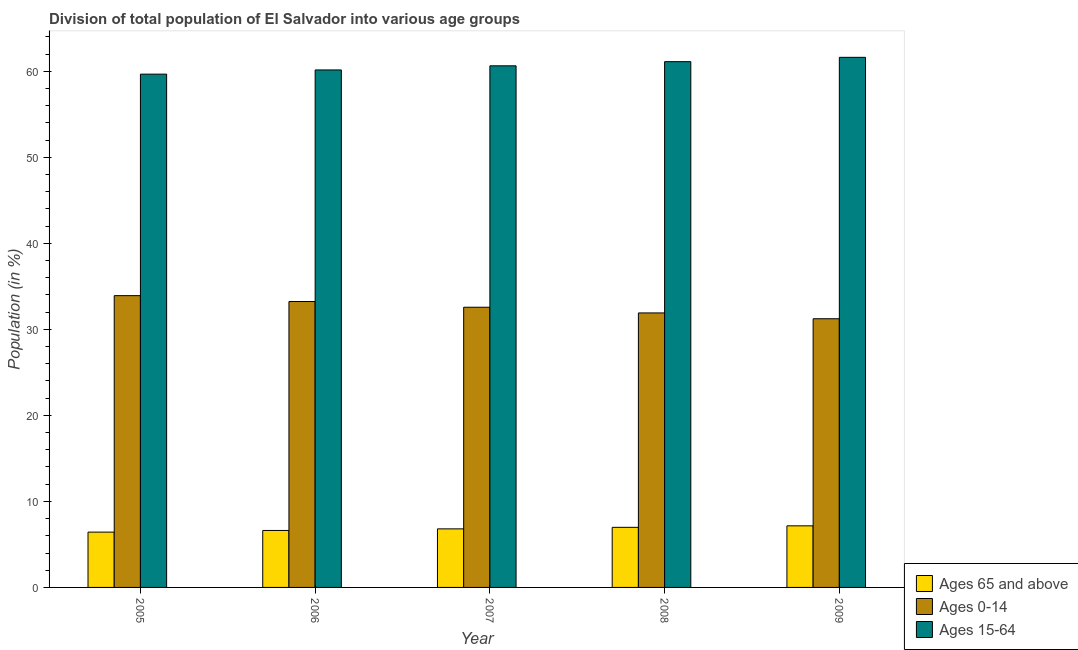How many different coloured bars are there?
Give a very brief answer. 3. How many bars are there on the 2nd tick from the left?
Ensure brevity in your answer.  3. How many bars are there on the 4th tick from the right?
Keep it short and to the point. 3. In how many cases, is the number of bars for a given year not equal to the number of legend labels?
Offer a terse response. 0. What is the percentage of population within the age-group of 65 and above in 2006?
Provide a short and direct response. 6.62. Across all years, what is the maximum percentage of population within the age-group of 65 and above?
Keep it short and to the point. 7.16. Across all years, what is the minimum percentage of population within the age-group 0-14?
Make the answer very short. 31.23. In which year was the percentage of population within the age-group 0-14 minimum?
Make the answer very short. 2009. What is the total percentage of population within the age-group 15-64 in the graph?
Keep it short and to the point. 303.16. What is the difference between the percentage of population within the age-group 0-14 in 2006 and that in 2009?
Your answer should be compact. 2. What is the difference between the percentage of population within the age-group 0-14 in 2008 and the percentage of population within the age-group 15-64 in 2009?
Provide a short and direct response. 0.68. What is the average percentage of population within the age-group of 65 and above per year?
Your response must be concise. 6.8. In the year 2008, what is the difference between the percentage of population within the age-group 15-64 and percentage of population within the age-group of 65 and above?
Keep it short and to the point. 0. What is the ratio of the percentage of population within the age-group 15-64 in 2008 to that in 2009?
Give a very brief answer. 0.99. Is the percentage of population within the age-group of 65 and above in 2005 less than that in 2006?
Offer a terse response. Yes. What is the difference between the highest and the second highest percentage of population within the age-group 0-14?
Your answer should be very brief. 0.68. What is the difference between the highest and the lowest percentage of population within the age-group 0-14?
Give a very brief answer. 2.68. Is the sum of the percentage of population within the age-group 15-64 in 2006 and 2007 greater than the maximum percentage of population within the age-group 0-14 across all years?
Give a very brief answer. Yes. What does the 2nd bar from the left in 2005 represents?
Your answer should be compact. Ages 0-14. What does the 1st bar from the right in 2007 represents?
Make the answer very short. Ages 15-64. Does the graph contain any zero values?
Provide a succinct answer. No. Does the graph contain grids?
Offer a very short reply. No. How many legend labels are there?
Your response must be concise. 3. How are the legend labels stacked?
Give a very brief answer. Vertical. What is the title of the graph?
Give a very brief answer. Division of total population of El Salvador into various age groups
. Does "Social Protection and Labor" appear as one of the legend labels in the graph?
Give a very brief answer. No. What is the Population (in %) in Ages 65 and above in 2005?
Make the answer very short. 6.43. What is the Population (in %) of Ages 0-14 in 2005?
Ensure brevity in your answer.  33.91. What is the Population (in %) in Ages 15-64 in 2005?
Your answer should be compact. 59.66. What is the Population (in %) in Ages 65 and above in 2006?
Your response must be concise. 6.62. What is the Population (in %) of Ages 0-14 in 2006?
Provide a short and direct response. 33.23. What is the Population (in %) of Ages 15-64 in 2006?
Your response must be concise. 60.15. What is the Population (in %) in Ages 65 and above in 2007?
Provide a succinct answer. 6.81. What is the Population (in %) in Ages 0-14 in 2007?
Keep it short and to the point. 32.57. What is the Population (in %) of Ages 15-64 in 2007?
Offer a terse response. 60.63. What is the Population (in %) in Ages 65 and above in 2008?
Provide a short and direct response. 6.98. What is the Population (in %) of Ages 0-14 in 2008?
Offer a terse response. 31.91. What is the Population (in %) of Ages 15-64 in 2008?
Ensure brevity in your answer.  61.11. What is the Population (in %) in Ages 65 and above in 2009?
Make the answer very short. 7.16. What is the Population (in %) of Ages 0-14 in 2009?
Provide a succinct answer. 31.23. What is the Population (in %) in Ages 15-64 in 2009?
Your answer should be compact. 61.61. Across all years, what is the maximum Population (in %) in Ages 65 and above?
Offer a very short reply. 7.16. Across all years, what is the maximum Population (in %) of Ages 0-14?
Your answer should be compact. 33.91. Across all years, what is the maximum Population (in %) of Ages 15-64?
Provide a short and direct response. 61.61. Across all years, what is the minimum Population (in %) of Ages 65 and above?
Your answer should be compact. 6.43. Across all years, what is the minimum Population (in %) of Ages 0-14?
Provide a succinct answer. 31.23. Across all years, what is the minimum Population (in %) of Ages 15-64?
Ensure brevity in your answer.  59.66. What is the total Population (in %) of Ages 65 and above in the graph?
Your response must be concise. 34. What is the total Population (in %) in Ages 0-14 in the graph?
Offer a terse response. 162.84. What is the total Population (in %) in Ages 15-64 in the graph?
Your answer should be very brief. 303.16. What is the difference between the Population (in %) in Ages 65 and above in 2005 and that in 2006?
Make the answer very short. -0.19. What is the difference between the Population (in %) in Ages 0-14 in 2005 and that in 2006?
Your answer should be compact. 0.68. What is the difference between the Population (in %) in Ages 15-64 in 2005 and that in 2006?
Offer a terse response. -0.49. What is the difference between the Population (in %) of Ages 65 and above in 2005 and that in 2007?
Your answer should be compact. -0.38. What is the difference between the Population (in %) in Ages 0-14 in 2005 and that in 2007?
Your answer should be very brief. 1.35. What is the difference between the Population (in %) in Ages 15-64 in 2005 and that in 2007?
Provide a short and direct response. -0.97. What is the difference between the Population (in %) of Ages 65 and above in 2005 and that in 2008?
Keep it short and to the point. -0.56. What is the difference between the Population (in %) in Ages 0-14 in 2005 and that in 2008?
Your response must be concise. 2.01. What is the difference between the Population (in %) of Ages 15-64 in 2005 and that in 2008?
Give a very brief answer. -1.45. What is the difference between the Population (in %) in Ages 65 and above in 2005 and that in 2009?
Ensure brevity in your answer.  -0.73. What is the difference between the Population (in %) of Ages 0-14 in 2005 and that in 2009?
Keep it short and to the point. 2.68. What is the difference between the Population (in %) of Ages 15-64 in 2005 and that in 2009?
Make the answer very short. -1.95. What is the difference between the Population (in %) in Ages 65 and above in 2006 and that in 2007?
Your answer should be very brief. -0.18. What is the difference between the Population (in %) in Ages 0-14 in 2006 and that in 2007?
Provide a succinct answer. 0.66. What is the difference between the Population (in %) in Ages 15-64 in 2006 and that in 2007?
Keep it short and to the point. -0.48. What is the difference between the Population (in %) in Ages 65 and above in 2006 and that in 2008?
Give a very brief answer. -0.36. What is the difference between the Population (in %) of Ages 0-14 in 2006 and that in 2008?
Give a very brief answer. 1.33. What is the difference between the Population (in %) of Ages 15-64 in 2006 and that in 2008?
Keep it short and to the point. -0.96. What is the difference between the Population (in %) in Ages 65 and above in 2006 and that in 2009?
Your answer should be very brief. -0.54. What is the difference between the Population (in %) in Ages 0-14 in 2006 and that in 2009?
Ensure brevity in your answer.  2. What is the difference between the Population (in %) in Ages 15-64 in 2006 and that in 2009?
Provide a short and direct response. -1.47. What is the difference between the Population (in %) in Ages 65 and above in 2007 and that in 2008?
Offer a terse response. -0.18. What is the difference between the Population (in %) of Ages 0-14 in 2007 and that in 2008?
Provide a succinct answer. 0.66. What is the difference between the Population (in %) in Ages 15-64 in 2007 and that in 2008?
Keep it short and to the point. -0.48. What is the difference between the Population (in %) of Ages 65 and above in 2007 and that in 2009?
Offer a very short reply. -0.35. What is the difference between the Population (in %) of Ages 0-14 in 2007 and that in 2009?
Offer a terse response. 1.34. What is the difference between the Population (in %) in Ages 15-64 in 2007 and that in 2009?
Make the answer very short. -0.99. What is the difference between the Population (in %) in Ages 65 and above in 2008 and that in 2009?
Ensure brevity in your answer.  -0.17. What is the difference between the Population (in %) in Ages 0-14 in 2008 and that in 2009?
Provide a short and direct response. 0.68. What is the difference between the Population (in %) of Ages 15-64 in 2008 and that in 2009?
Your response must be concise. -0.5. What is the difference between the Population (in %) in Ages 65 and above in 2005 and the Population (in %) in Ages 0-14 in 2006?
Your response must be concise. -26.8. What is the difference between the Population (in %) in Ages 65 and above in 2005 and the Population (in %) in Ages 15-64 in 2006?
Your response must be concise. -53.72. What is the difference between the Population (in %) of Ages 0-14 in 2005 and the Population (in %) of Ages 15-64 in 2006?
Offer a very short reply. -26.24. What is the difference between the Population (in %) in Ages 65 and above in 2005 and the Population (in %) in Ages 0-14 in 2007?
Your answer should be very brief. -26.14. What is the difference between the Population (in %) of Ages 65 and above in 2005 and the Population (in %) of Ages 15-64 in 2007?
Offer a very short reply. -54.2. What is the difference between the Population (in %) of Ages 0-14 in 2005 and the Population (in %) of Ages 15-64 in 2007?
Provide a succinct answer. -26.71. What is the difference between the Population (in %) of Ages 65 and above in 2005 and the Population (in %) of Ages 0-14 in 2008?
Provide a short and direct response. -25.48. What is the difference between the Population (in %) of Ages 65 and above in 2005 and the Population (in %) of Ages 15-64 in 2008?
Keep it short and to the point. -54.68. What is the difference between the Population (in %) of Ages 0-14 in 2005 and the Population (in %) of Ages 15-64 in 2008?
Make the answer very short. -27.2. What is the difference between the Population (in %) in Ages 65 and above in 2005 and the Population (in %) in Ages 0-14 in 2009?
Your answer should be compact. -24.8. What is the difference between the Population (in %) of Ages 65 and above in 2005 and the Population (in %) of Ages 15-64 in 2009?
Give a very brief answer. -55.18. What is the difference between the Population (in %) in Ages 0-14 in 2005 and the Population (in %) in Ages 15-64 in 2009?
Make the answer very short. -27.7. What is the difference between the Population (in %) in Ages 65 and above in 2006 and the Population (in %) in Ages 0-14 in 2007?
Offer a very short reply. -25.94. What is the difference between the Population (in %) in Ages 65 and above in 2006 and the Population (in %) in Ages 15-64 in 2007?
Keep it short and to the point. -54. What is the difference between the Population (in %) in Ages 0-14 in 2006 and the Population (in %) in Ages 15-64 in 2007?
Provide a succinct answer. -27.4. What is the difference between the Population (in %) in Ages 65 and above in 2006 and the Population (in %) in Ages 0-14 in 2008?
Offer a terse response. -25.28. What is the difference between the Population (in %) in Ages 65 and above in 2006 and the Population (in %) in Ages 15-64 in 2008?
Offer a terse response. -54.49. What is the difference between the Population (in %) in Ages 0-14 in 2006 and the Population (in %) in Ages 15-64 in 2008?
Provide a succinct answer. -27.88. What is the difference between the Population (in %) of Ages 65 and above in 2006 and the Population (in %) of Ages 0-14 in 2009?
Offer a terse response. -24.61. What is the difference between the Population (in %) in Ages 65 and above in 2006 and the Population (in %) in Ages 15-64 in 2009?
Offer a very short reply. -54.99. What is the difference between the Population (in %) in Ages 0-14 in 2006 and the Population (in %) in Ages 15-64 in 2009?
Keep it short and to the point. -28.38. What is the difference between the Population (in %) of Ages 65 and above in 2007 and the Population (in %) of Ages 0-14 in 2008?
Your response must be concise. -25.1. What is the difference between the Population (in %) of Ages 65 and above in 2007 and the Population (in %) of Ages 15-64 in 2008?
Offer a terse response. -54.3. What is the difference between the Population (in %) of Ages 0-14 in 2007 and the Population (in %) of Ages 15-64 in 2008?
Give a very brief answer. -28.54. What is the difference between the Population (in %) in Ages 65 and above in 2007 and the Population (in %) in Ages 0-14 in 2009?
Offer a very short reply. -24.42. What is the difference between the Population (in %) of Ages 65 and above in 2007 and the Population (in %) of Ages 15-64 in 2009?
Offer a very short reply. -54.81. What is the difference between the Population (in %) of Ages 0-14 in 2007 and the Population (in %) of Ages 15-64 in 2009?
Make the answer very short. -29.05. What is the difference between the Population (in %) in Ages 65 and above in 2008 and the Population (in %) in Ages 0-14 in 2009?
Offer a terse response. -24.24. What is the difference between the Population (in %) in Ages 65 and above in 2008 and the Population (in %) in Ages 15-64 in 2009?
Ensure brevity in your answer.  -54.63. What is the difference between the Population (in %) in Ages 0-14 in 2008 and the Population (in %) in Ages 15-64 in 2009?
Provide a succinct answer. -29.71. What is the average Population (in %) of Ages 65 and above per year?
Keep it short and to the point. 6.8. What is the average Population (in %) in Ages 0-14 per year?
Provide a short and direct response. 32.57. What is the average Population (in %) of Ages 15-64 per year?
Provide a succinct answer. 60.63. In the year 2005, what is the difference between the Population (in %) of Ages 65 and above and Population (in %) of Ages 0-14?
Offer a terse response. -27.48. In the year 2005, what is the difference between the Population (in %) in Ages 65 and above and Population (in %) in Ages 15-64?
Offer a terse response. -53.23. In the year 2005, what is the difference between the Population (in %) in Ages 0-14 and Population (in %) in Ages 15-64?
Give a very brief answer. -25.75. In the year 2006, what is the difference between the Population (in %) of Ages 65 and above and Population (in %) of Ages 0-14?
Make the answer very short. -26.61. In the year 2006, what is the difference between the Population (in %) of Ages 65 and above and Population (in %) of Ages 15-64?
Your response must be concise. -53.53. In the year 2006, what is the difference between the Population (in %) of Ages 0-14 and Population (in %) of Ages 15-64?
Offer a terse response. -26.92. In the year 2007, what is the difference between the Population (in %) in Ages 65 and above and Population (in %) in Ages 0-14?
Offer a very short reply. -25.76. In the year 2007, what is the difference between the Population (in %) of Ages 65 and above and Population (in %) of Ages 15-64?
Provide a short and direct response. -53.82. In the year 2007, what is the difference between the Population (in %) in Ages 0-14 and Population (in %) in Ages 15-64?
Provide a succinct answer. -28.06. In the year 2008, what is the difference between the Population (in %) of Ages 65 and above and Population (in %) of Ages 0-14?
Your answer should be very brief. -24.92. In the year 2008, what is the difference between the Population (in %) in Ages 65 and above and Population (in %) in Ages 15-64?
Give a very brief answer. -54.13. In the year 2008, what is the difference between the Population (in %) in Ages 0-14 and Population (in %) in Ages 15-64?
Offer a very short reply. -29.2. In the year 2009, what is the difference between the Population (in %) in Ages 65 and above and Population (in %) in Ages 0-14?
Offer a terse response. -24.07. In the year 2009, what is the difference between the Population (in %) of Ages 65 and above and Population (in %) of Ages 15-64?
Provide a succinct answer. -54.46. In the year 2009, what is the difference between the Population (in %) of Ages 0-14 and Population (in %) of Ages 15-64?
Provide a short and direct response. -30.38. What is the ratio of the Population (in %) in Ages 65 and above in 2005 to that in 2006?
Give a very brief answer. 0.97. What is the ratio of the Population (in %) in Ages 0-14 in 2005 to that in 2006?
Your answer should be very brief. 1.02. What is the ratio of the Population (in %) in Ages 65 and above in 2005 to that in 2007?
Your answer should be compact. 0.94. What is the ratio of the Population (in %) of Ages 0-14 in 2005 to that in 2007?
Make the answer very short. 1.04. What is the ratio of the Population (in %) of Ages 15-64 in 2005 to that in 2007?
Your answer should be very brief. 0.98. What is the ratio of the Population (in %) in Ages 65 and above in 2005 to that in 2008?
Keep it short and to the point. 0.92. What is the ratio of the Population (in %) in Ages 0-14 in 2005 to that in 2008?
Offer a terse response. 1.06. What is the ratio of the Population (in %) of Ages 15-64 in 2005 to that in 2008?
Your response must be concise. 0.98. What is the ratio of the Population (in %) of Ages 65 and above in 2005 to that in 2009?
Offer a terse response. 0.9. What is the ratio of the Population (in %) of Ages 0-14 in 2005 to that in 2009?
Offer a very short reply. 1.09. What is the ratio of the Population (in %) of Ages 15-64 in 2005 to that in 2009?
Your answer should be very brief. 0.97. What is the ratio of the Population (in %) of Ages 65 and above in 2006 to that in 2007?
Make the answer very short. 0.97. What is the ratio of the Population (in %) of Ages 0-14 in 2006 to that in 2007?
Your answer should be very brief. 1.02. What is the ratio of the Population (in %) in Ages 65 and above in 2006 to that in 2008?
Keep it short and to the point. 0.95. What is the ratio of the Population (in %) in Ages 0-14 in 2006 to that in 2008?
Keep it short and to the point. 1.04. What is the ratio of the Population (in %) of Ages 15-64 in 2006 to that in 2008?
Ensure brevity in your answer.  0.98. What is the ratio of the Population (in %) in Ages 65 and above in 2006 to that in 2009?
Keep it short and to the point. 0.93. What is the ratio of the Population (in %) of Ages 0-14 in 2006 to that in 2009?
Your answer should be compact. 1.06. What is the ratio of the Population (in %) of Ages 15-64 in 2006 to that in 2009?
Provide a short and direct response. 0.98. What is the ratio of the Population (in %) of Ages 65 and above in 2007 to that in 2008?
Offer a terse response. 0.97. What is the ratio of the Population (in %) of Ages 0-14 in 2007 to that in 2008?
Provide a short and direct response. 1.02. What is the ratio of the Population (in %) of Ages 15-64 in 2007 to that in 2008?
Provide a short and direct response. 0.99. What is the ratio of the Population (in %) of Ages 65 and above in 2007 to that in 2009?
Give a very brief answer. 0.95. What is the ratio of the Population (in %) in Ages 0-14 in 2007 to that in 2009?
Your answer should be compact. 1.04. What is the ratio of the Population (in %) of Ages 15-64 in 2007 to that in 2009?
Provide a short and direct response. 0.98. What is the ratio of the Population (in %) of Ages 65 and above in 2008 to that in 2009?
Your answer should be compact. 0.98. What is the ratio of the Population (in %) in Ages 0-14 in 2008 to that in 2009?
Ensure brevity in your answer.  1.02. What is the ratio of the Population (in %) in Ages 15-64 in 2008 to that in 2009?
Ensure brevity in your answer.  0.99. What is the difference between the highest and the second highest Population (in %) of Ages 65 and above?
Make the answer very short. 0.17. What is the difference between the highest and the second highest Population (in %) in Ages 0-14?
Offer a terse response. 0.68. What is the difference between the highest and the second highest Population (in %) in Ages 15-64?
Provide a succinct answer. 0.5. What is the difference between the highest and the lowest Population (in %) of Ages 65 and above?
Ensure brevity in your answer.  0.73. What is the difference between the highest and the lowest Population (in %) in Ages 0-14?
Your answer should be compact. 2.68. What is the difference between the highest and the lowest Population (in %) of Ages 15-64?
Provide a succinct answer. 1.95. 